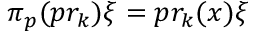Convert formula to latex. <formula><loc_0><loc_0><loc_500><loc_500>\pi _ { p } ( p r _ { k } ) \xi = p r _ { k } ( x ) \xi</formula> 